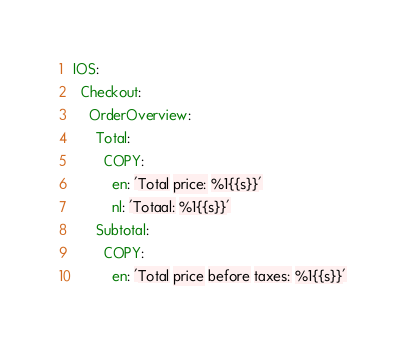<code> <loc_0><loc_0><loc_500><loc_500><_YAML_>IOS:
  Checkout:
    OrderOverview:
      Total:
        COPY:
          en: 'Total price: %1{{s}}'
          nl: 'Totaal: %1{{s}}'
      Subtotal:
        COPY:
          en: 'Total price before taxes: %1{{s}}'
</code> 